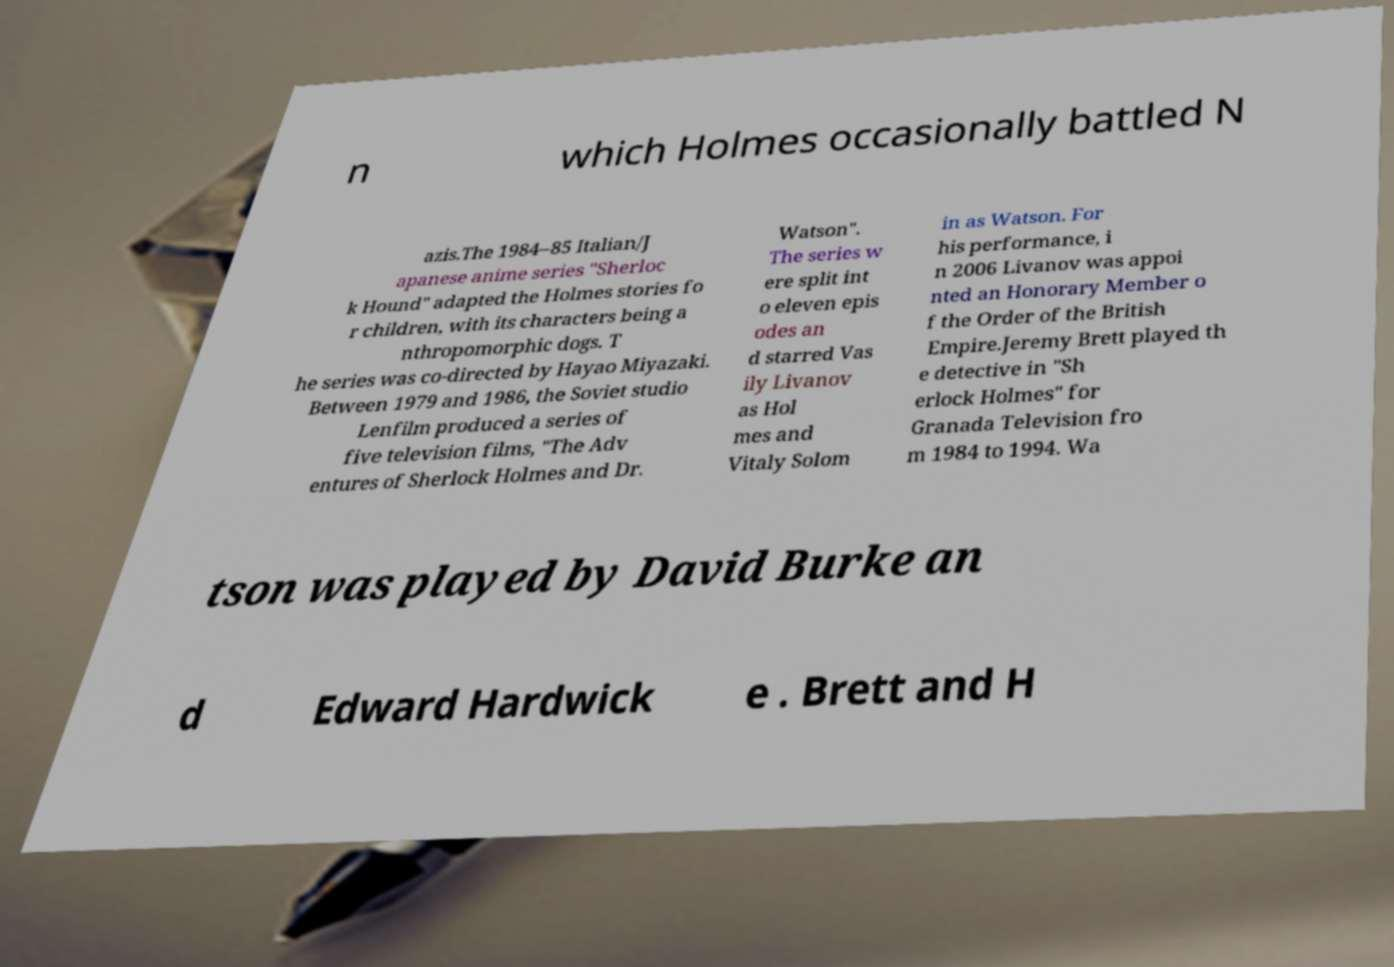Could you assist in decoding the text presented in this image and type it out clearly? n which Holmes occasionally battled N azis.The 1984–85 Italian/J apanese anime series "Sherloc k Hound" adapted the Holmes stories fo r children, with its characters being a nthropomorphic dogs. T he series was co-directed by Hayao Miyazaki. Between 1979 and 1986, the Soviet studio Lenfilm produced a series of five television films, "The Adv entures of Sherlock Holmes and Dr. Watson". The series w ere split int o eleven epis odes an d starred Vas ily Livanov as Hol mes and Vitaly Solom in as Watson. For his performance, i n 2006 Livanov was appoi nted an Honorary Member o f the Order of the British Empire.Jeremy Brett played th e detective in "Sh erlock Holmes" for Granada Television fro m 1984 to 1994. Wa tson was played by David Burke an d Edward Hardwick e . Brett and H 